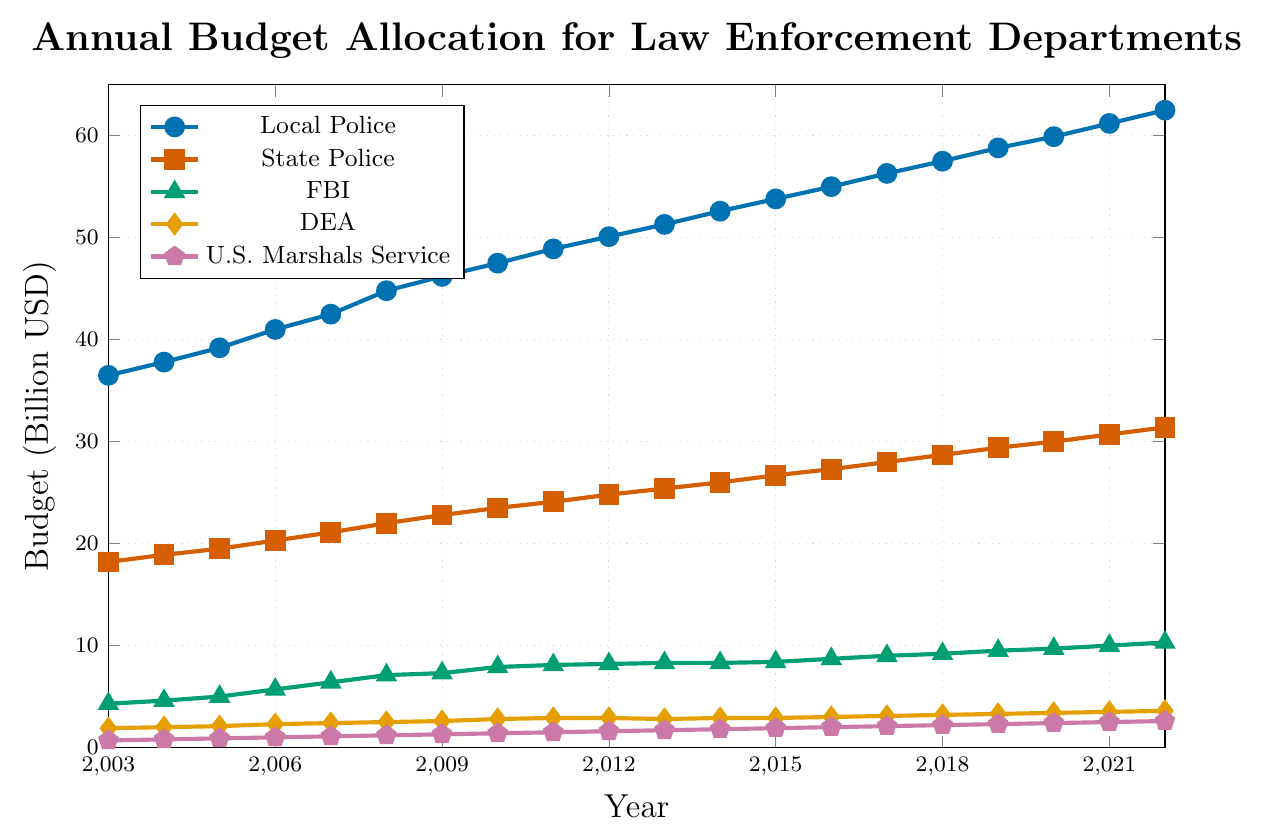What's the budget allocation for the Local Police in 2010? Identify the data point on the line for Local Police in the year 2010. The value is approximately 47.5 billion USD.
Answer: 47.5 billion USD How does the budget for the DEA in 2022 compare to that in 2003? Locate the data points for the DEA in 2022 and 2003. In 2003, it's 1.9 billion USD, and in 2022, it's 3.6 billion USD. The budget increased by (3.6 - 1.9) = 1.7 billion USD.
Answer: Increased by 1.7 billion USD What was the average annual budget for the FBI between 2010 and 2020? Sum the FBI budgets from 2010 to 2020 and divide by the number of years:
(7.9 + 8.1 + 8.2 + 8.3 + 8.3 + 8.4 + 8.7 + 9.0 + 9.2 + 9.5 + 9.7) / 11 = 95.3 / 11 ≈ 8.66 billion USD.
Answer: Approximately 8.66 billion USD In which year did the State Police first surpass a 25 billion USD budget? Track the State Police budget by year until it exceeds 25 billion USD. In 2013, the budget was 25.4 billion USD, the first year it surpassed 25 billion USD.
Answer: 2013 Comparing 2003 and 2022, by how much did the U.S. Marshals Service budget increase proportionally? Calculate the proportional increase as ((2022 budget - 2003 budget) / 2003 budget) * 100:
((2.6 - 0.7) / 0.7) * 100 ≈ 271.43%.
Answer: Approximately 271.43% What's the combined budget for all departments in 2021? Sum the budgets of all departments in 2021: 
61.2 + 30.7 + 10.0 + 3.5 + 2.5 = 107.9 billion USD.
Answer: 107.9 billion USD 